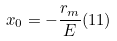<formula> <loc_0><loc_0><loc_500><loc_500>x _ { 0 } = - \frac { r _ { m } } { E } ( 1 1 )</formula> 